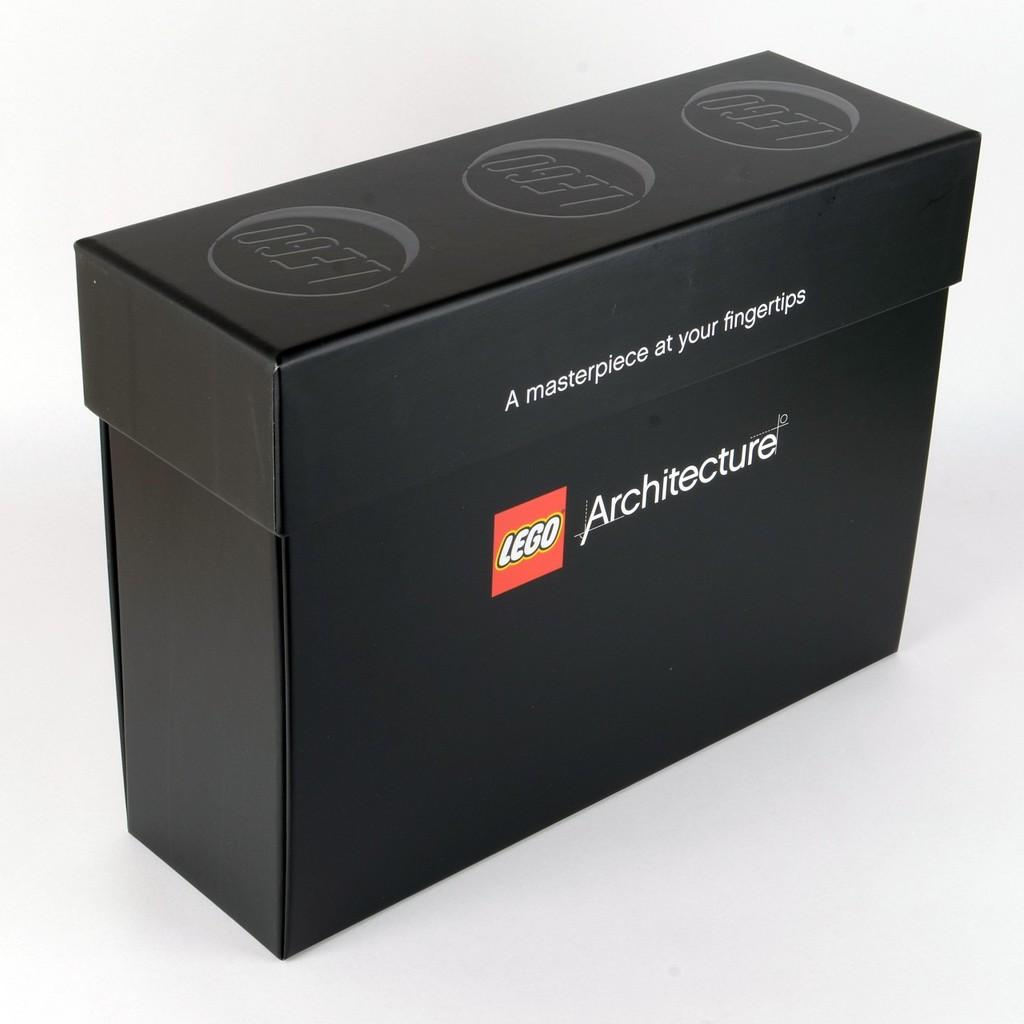<image>
Render a clear and concise summary of the photo. Lego Architecture Box with a saying: A Masterpiece at your fingertips. 